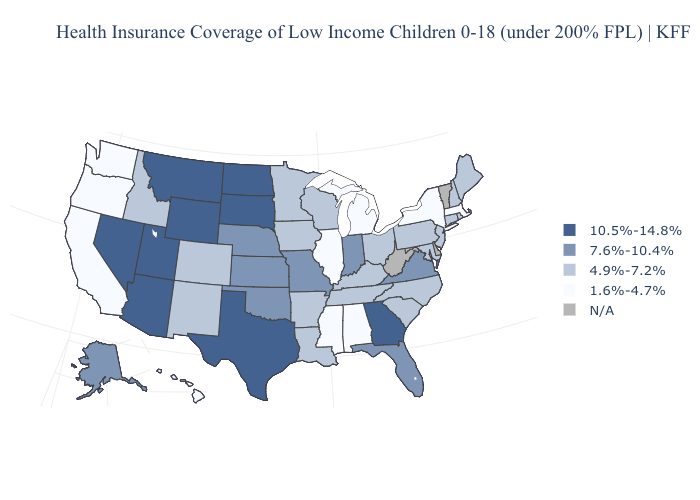What is the value of North Carolina?
Give a very brief answer. 4.9%-7.2%. Name the states that have a value in the range N/A?
Answer briefly. Delaware, Vermont, West Virginia. Name the states that have a value in the range 10.5%-14.8%?
Concise answer only. Arizona, Georgia, Montana, Nevada, North Dakota, South Dakota, Texas, Utah, Wyoming. Name the states that have a value in the range N/A?
Short answer required. Delaware, Vermont, West Virginia. What is the highest value in the Northeast ?
Give a very brief answer. 4.9%-7.2%. Does New York have the highest value in the Northeast?
Write a very short answer. No. What is the highest value in the MidWest ?
Short answer required. 10.5%-14.8%. What is the value of Nebraska?
Write a very short answer. 7.6%-10.4%. What is the value of Minnesota?
Give a very brief answer. 4.9%-7.2%. Which states hav the highest value in the Northeast?
Quick response, please. Connecticut, Maine, New Hampshire, New Jersey, Pennsylvania, Rhode Island. Name the states that have a value in the range 7.6%-10.4%?
Be succinct. Alaska, Florida, Indiana, Kansas, Missouri, Nebraska, Oklahoma, Virginia. Among the states that border Tennessee , does Virginia have the lowest value?
Write a very short answer. No. What is the value of Mississippi?
Concise answer only. 1.6%-4.7%. Which states hav the highest value in the MidWest?
Be succinct. North Dakota, South Dakota. Which states have the highest value in the USA?
Quick response, please. Arizona, Georgia, Montana, Nevada, North Dakota, South Dakota, Texas, Utah, Wyoming. 